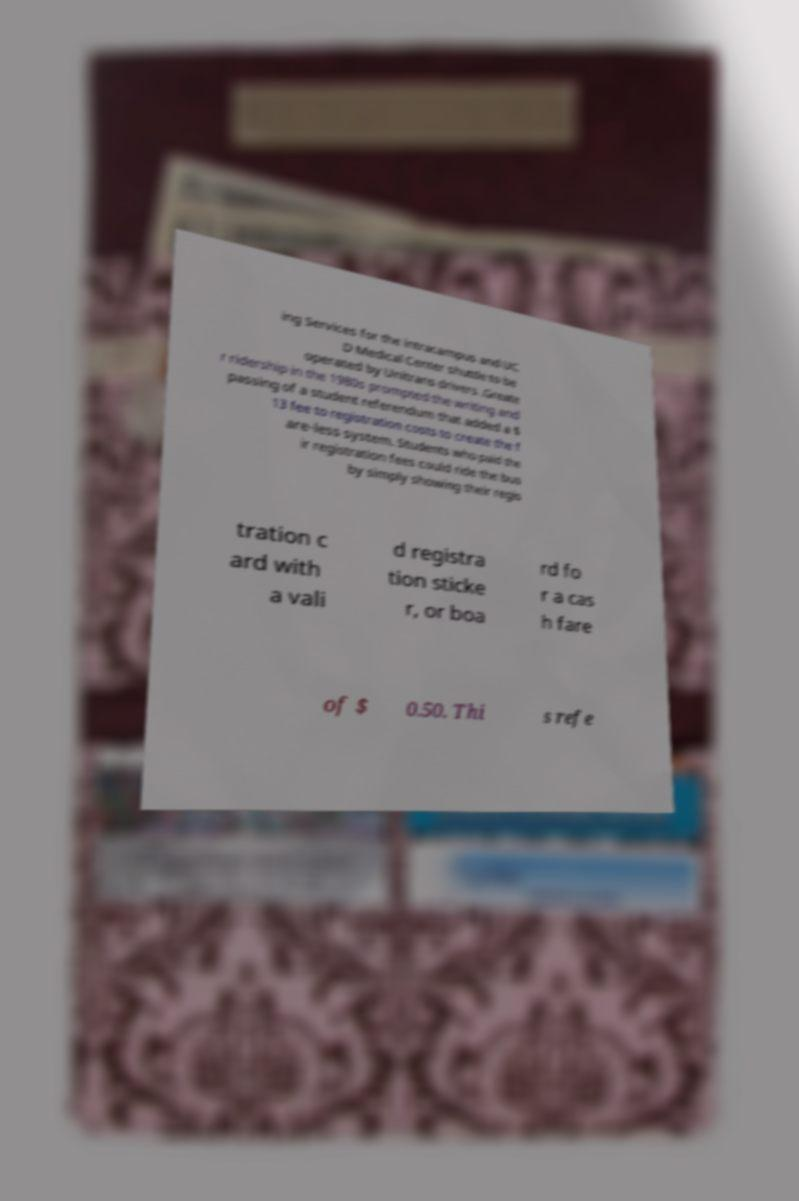Can you read and provide the text displayed in the image?This photo seems to have some interesting text. Can you extract and type it out for me? ing Services for the intracampus and UC D Medical Center shuttle to be operated by Unitrans drivers .Greate r ridership in the 1980s prompted the writing and passing of a student referendum that added a $ 13 fee to registration costs to create the f are-less system. Students who paid the ir registration fees could ride the bus by simply showing their regis tration c ard with a vali d registra tion sticke r, or boa rd fo r a cas h fare of $ 0.50. Thi s refe 